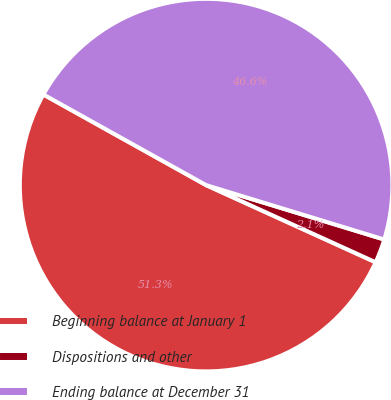<chart> <loc_0><loc_0><loc_500><loc_500><pie_chart><fcel>Beginning balance at January 1<fcel>Dispositions and other<fcel>Ending balance at December 31<nl><fcel>51.29%<fcel>2.08%<fcel>46.63%<nl></chart> 